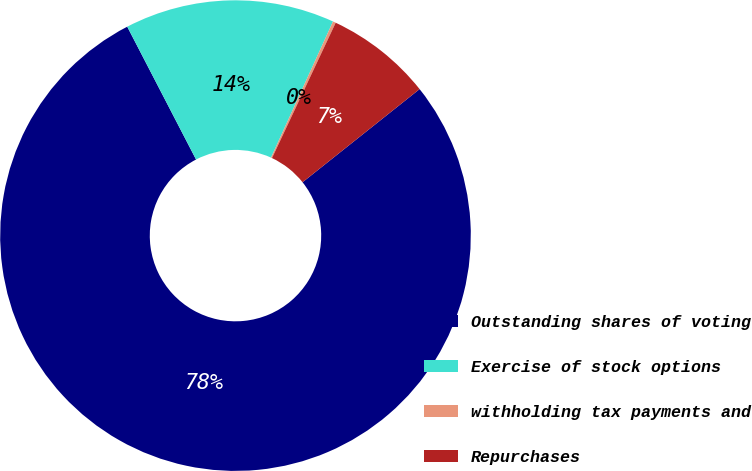<chart> <loc_0><loc_0><loc_500><loc_500><pie_chart><fcel>Outstanding shares of voting<fcel>Exercise of stock options<fcel>withholding tax payments and<fcel>Repurchases<nl><fcel>78.09%<fcel>14.41%<fcel>0.2%<fcel>7.3%<nl></chart> 